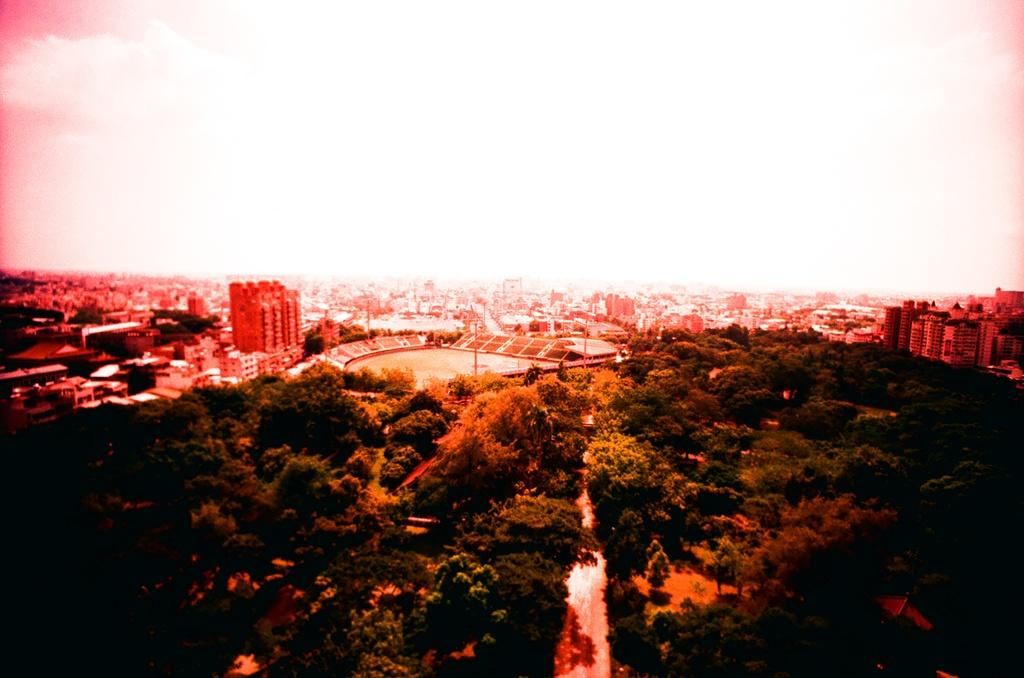What type of natural elements can be seen in the image? There are trees in the image. What type of man-made structures are present in the image? There are buildings and a stadium in the image. What are the tall, thin objects in the image? There are poles in the image. What is visible at the top of the image? The sky is visible at the top of the image. Can you tell me how many dimes are scattered on the ground in the image? There are no dimes present in the image. What type of dock can be seen near the stadium in the image? There is no dock present in the image. 